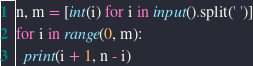Convert code to text. <code><loc_0><loc_0><loc_500><loc_500><_Python_>n, m = [int(i) for i in input().split(' ')]
for i in range(0, m):
  print(i + 1, n - i)</code> 